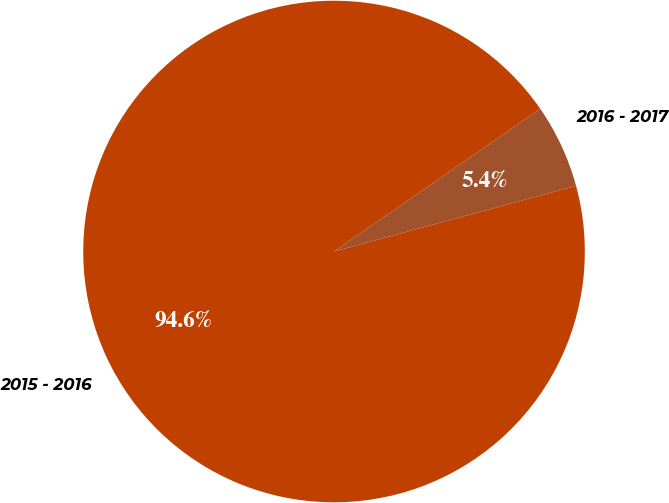Convert chart. <chart><loc_0><loc_0><loc_500><loc_500><pie_chart><fcel>2016 - 2017<fcel>2015 - 2016<nl><fcel>5.42%<fcel>94.58%<nl></chart> 